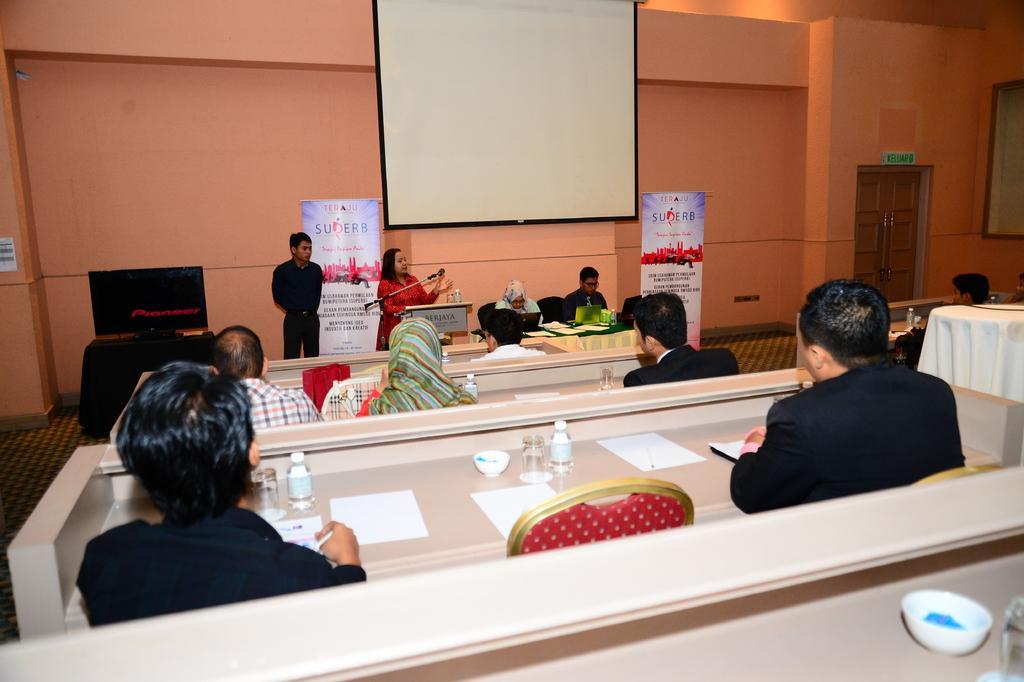Describe this image in one or two sentences. In a room there are some people sitting on the red color chair. In front of them there is a table with glass, paper, bottle and a bowl on it. In front there is a lady with red dress is standing in front of the podium and there is a mic. Beside her there is a man with black dress. In the background there is a screen and in the right side there is a wall. 